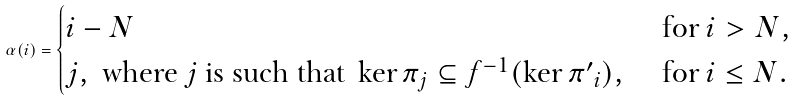Convert formula to latex. <formula><loc_0><loc_0><loc_500><loc_500>\alpha ( i ) = \begin{cases} i - N & \text { for } i > N , \\ j , \text { where $j$ is such that } \ker \pi _ { j } \subseteq f ^ { - 1 } ( \ker { \pi ^ { \prime } } _ { i } ) , & \text { for } i \leq N . \end{cases}</formula> 